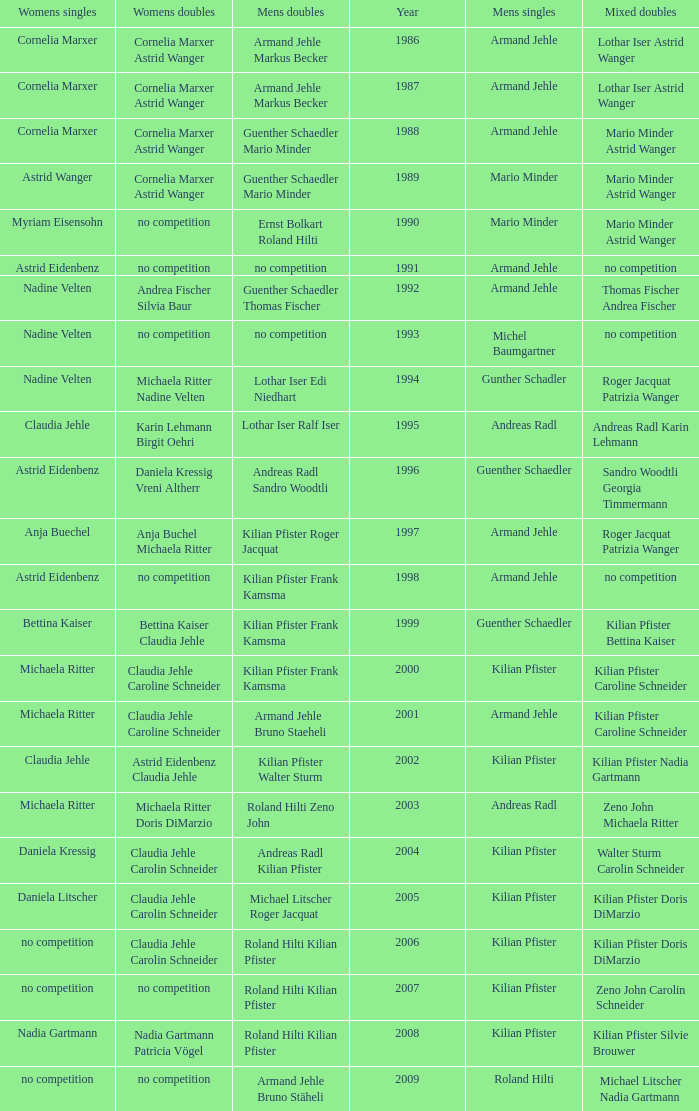What is the most current year where the women's doubles champions are astrid eidenbenz claudia jehle 2002.0. 